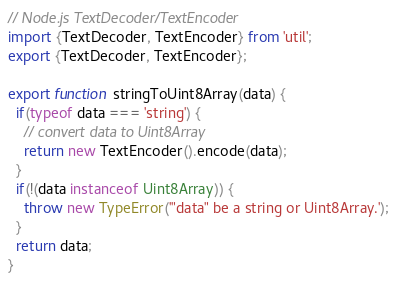Convert code to text. <code><loc_0><loc_0><loc_500><loc_500><_JavaScript_>// Node.js TextDecoder/TextEncoder
import {TextDecoder, TextEncoder} from 'util';
export {TextDecoder, TextEncoder};

export function stringToUint8Array(data) {
  if(typeof data === 'string') {
    // convert data to Uint8Array
    return new TextEncoder().encode(data);
  }
  if(!(data instanceof Uint8Array)) {
    throw new TypeError('"data" be a string or Uint8Array.');
  }
  return data;
}
</code> 